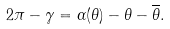Convert formula to latex. <formula><loc_0><loc_0><loc_500><loc_500>2 \pi - \gamma = \alpha ( \theta ) - \theta - \overline { \theta } .</formula> 